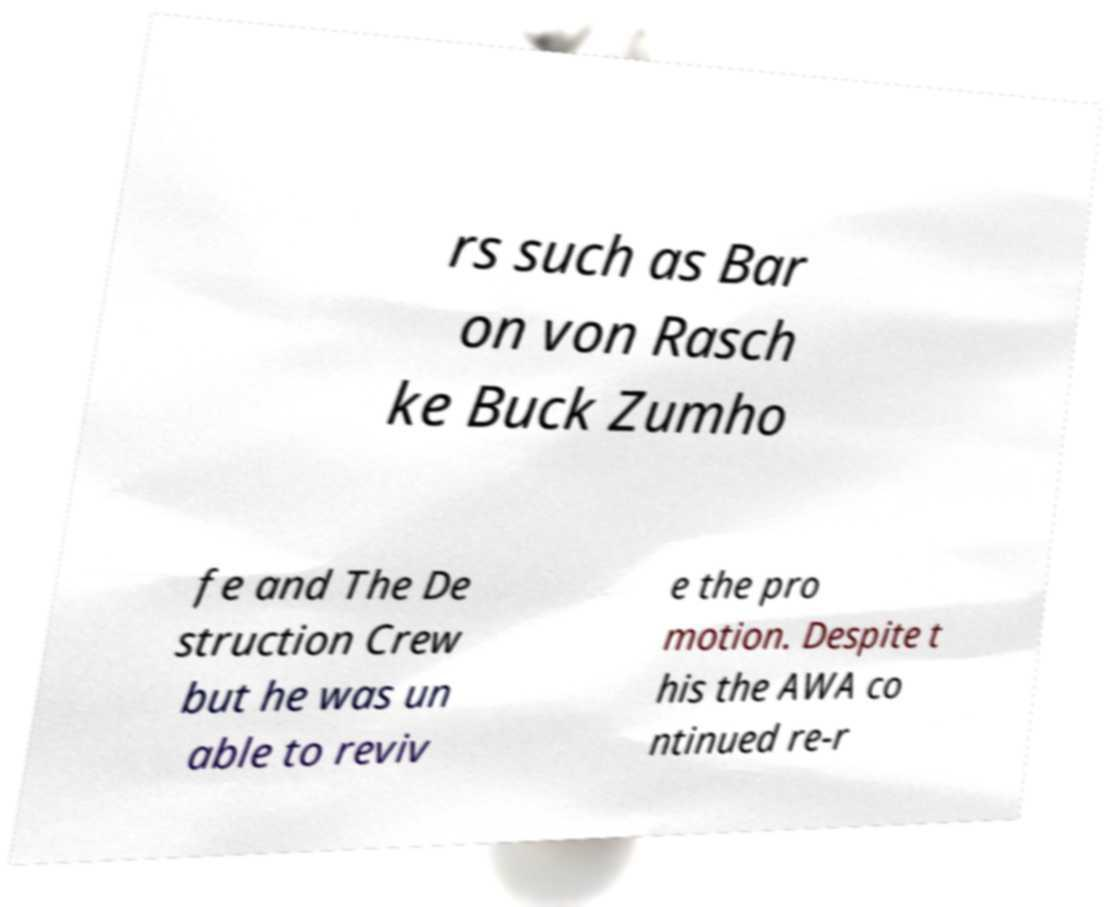Could you extract and type out the text from this image? rs such as Bar on von Rasch ke Buck Zumho fe and The De struction Crew but he was un able to reviv e the pro motion. Despite t his the AWA co ntinued re-r 